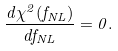<formula> <loc_0><loc_0><loc_500><loc_500>\frac { d \chi ^ { 2 } ( f _ { N L } ) } { d f _ { N L } } = 0 .</formula> 